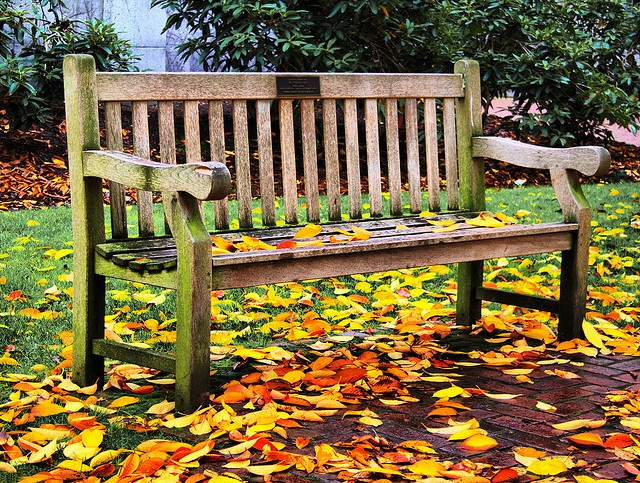Describe the objects in this image and their specific colors. I can see a bench in teal, black, tan, and olive tones in this image. 